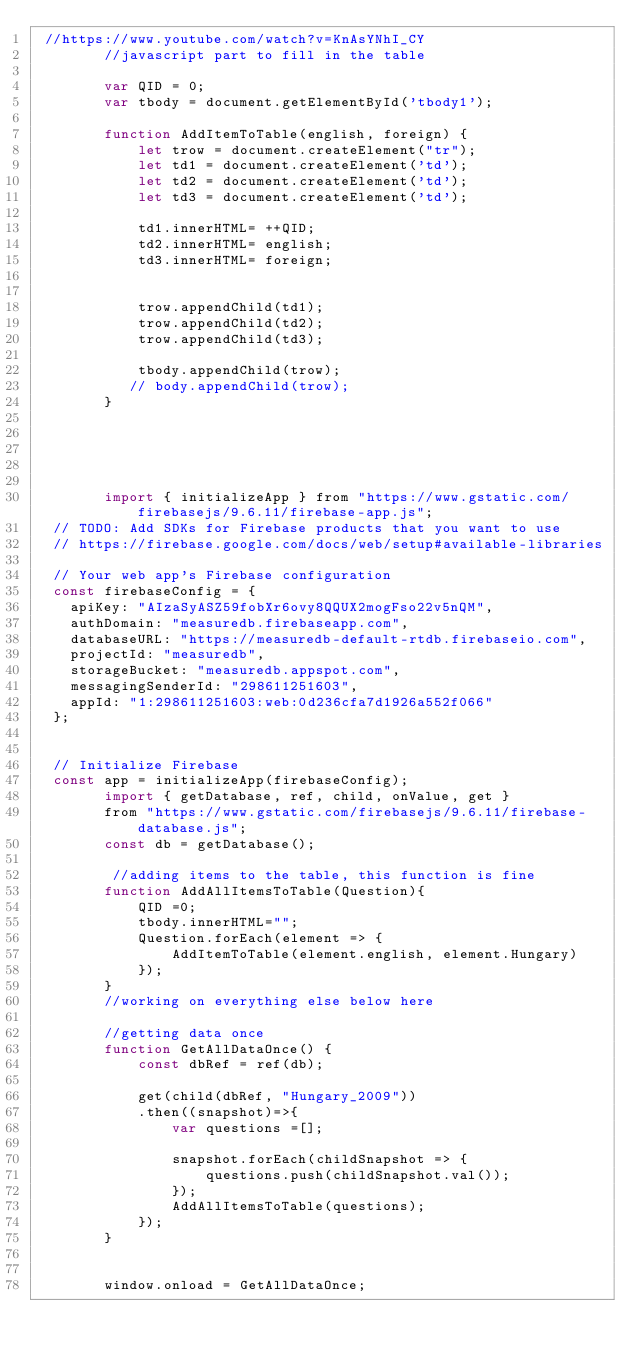Convert code to text. <code><loc_0><loc_0><loc_500><loc_500><_JavaScript_> //https://www.youtube.com/watch?v=KnAsYNhI_CY
        //javascript part to fill in the table

        var QID = 0;
        var tbody = document.getElementById('tbody1');

        function AddItemToTable(english, foreign) {
            let trow = document.createElement("tr");
            let td1 = document.createElement('td');
            let td2 = document.createElement('td');
            let td3 = document.createElement('td');

            td1.innerHTML= ++QID;
            td2.innerHTML= english;
            td3.innerHTML= foreign;


            trow.appendChild(td1);
            trow.appendChild(td2);
            trow.appendChild(td3);

            tbody.appendChild(trow);
           // body.appendChild(trow);
        }

        
    


        import { initializeApp } from "https://www.gstatic.com/firebasejs/9.6.11/firebase-app.js";
  // TODO: Add SDKs for Firebase products that you want to use
  // https://firebase.google.com/docs/web/setup#available-libraries

  // Your web app's Firebase configuration
  const firebaseConfig = {
    apiKey: "AIzaSyASZ59fobXr6ovy8QQUX2mogFso22v5nQM",
    authDomain: "measuredb.firebaseapp.com",
    databaseURL: "https://measuredb-default-rtdb.firebaseio.com",
    projectId: "measuredb",
    storageBucket: "measuredb.appspot.com",
    messagingSenderId: "298611251603",
    appId: "1:298611251603:web:0d236cfa7d1926a552f066"
  };
    

  // Initialize Firebase
  const app = initializeApp(firebaseConfig);
        import { getDatabase, ref, child, onValue, get }
        from "https://www.gstatic.com/firebasejs/9.6.11/firebase-database.js";
        const db = getDatabase();

         //adding items to the table, this function is fine
        function AddAllItemsToTable(Question){    
            QID =0;
            tbody.innerHTML="";
            Question.forEach(element => {
                AddItemToTable(element.english, element.Hungary)
            });
        }
        //working on everything else below here

        //getting data once
        function GetAllDataOnce() {
            const dbRef = ref(db);

            get(child(dbRef, "Hungary_2009"))
            .then((snapshot)=>{
                var questions =[];
                
                snapshot.forEach(childSnapshot => {
                    questions.push(childSnapshot.val());
                });
                AddAllItemsToTable(questions);
            });
        }


        window.onload = GetAllDataOnce;</code> 